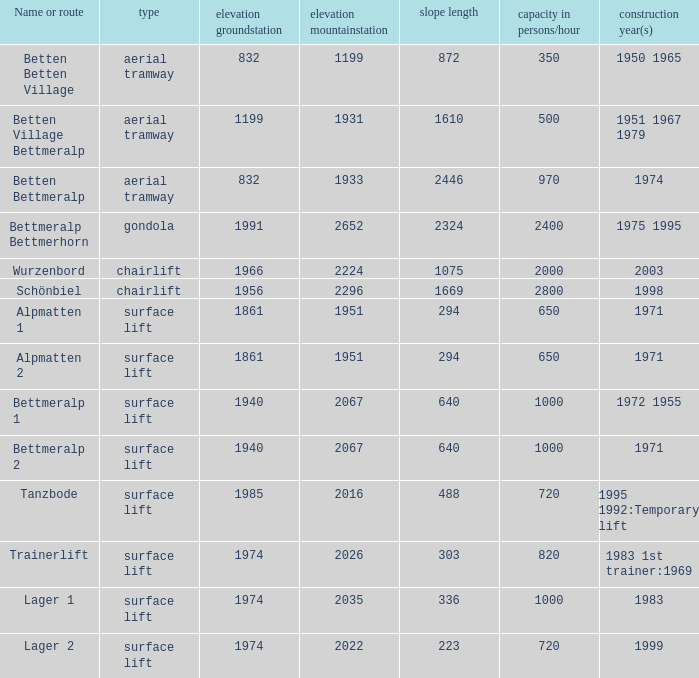Which gradient length possesses a form of surface lift, an elevation groundstation below 1974, a building year of 1971, and a name or pathway of alpmatten 1? 294.0. 